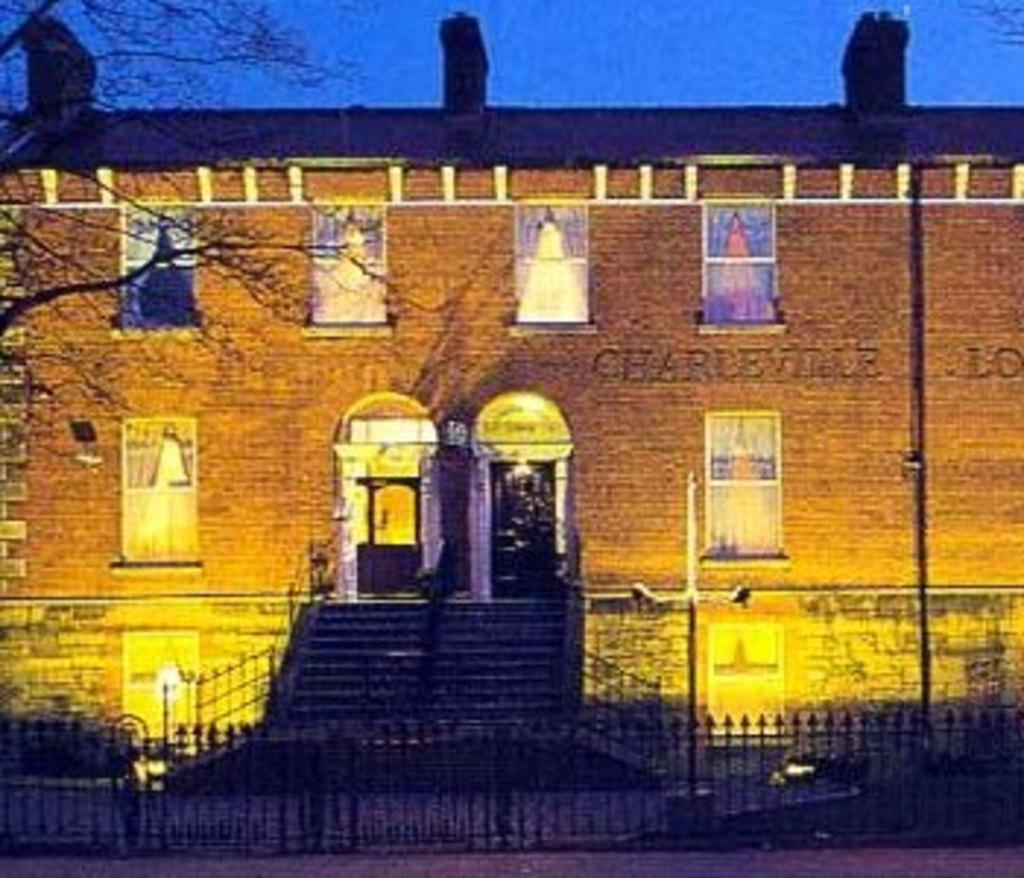What type of structure is present in the image? There is a building in the image. What is located near the building? There is a fence in the image. What else can be seen in the image? There are poles, pictures, and branches visible. What is visible in the background of the image? The sky is visible in the background of the image. What type of pancake is being served at the event in the image? There is no event or pancake present in the image. How many days are represented in the image? The image does not depict a specific time period or week, so it is not possible to determine the number of days represented. 